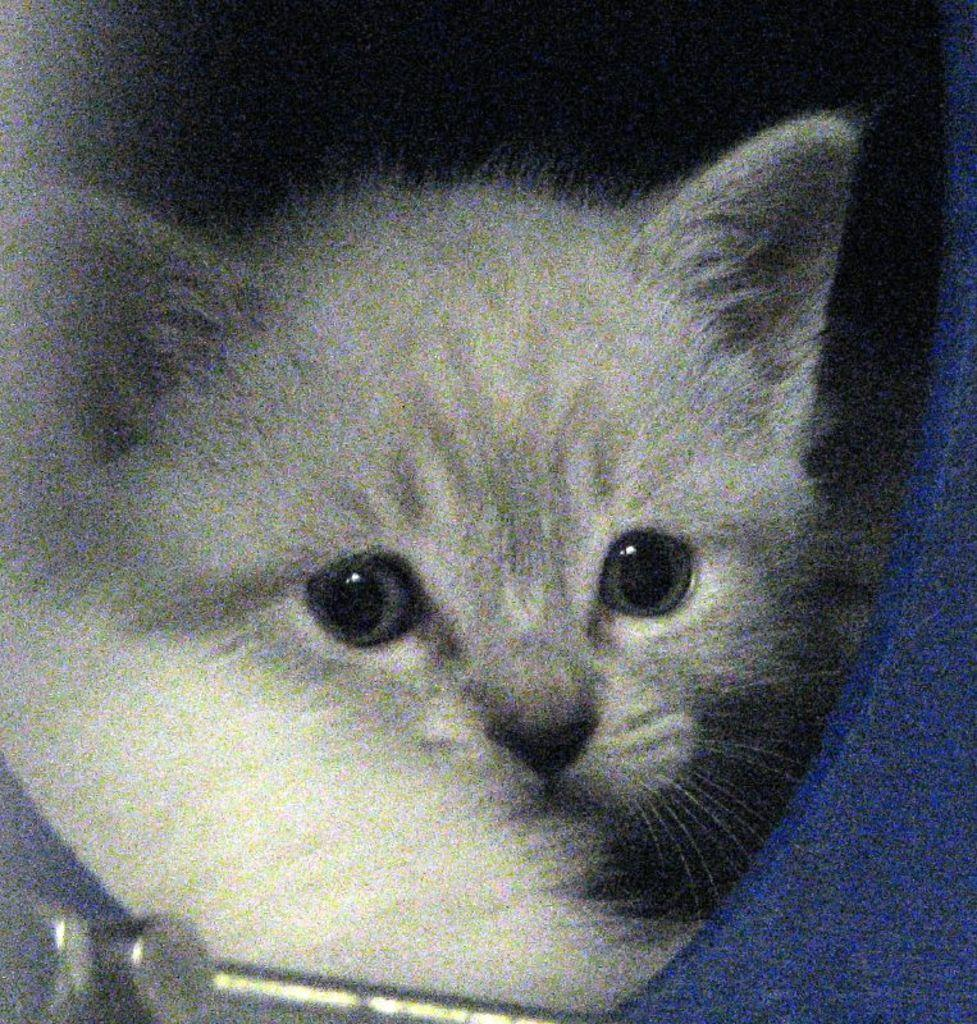What type of animal is in the image? There is a white color cat in the image. Where is the cat located in the image? The cat is present in the middle of the image. What type of arithmetic problem is the cat solving in the image? There is no arithmetic problem present in the image; it features a white color cat. How does the cat manage to burn itself in the image? There is no indication in the image that the cat is burning or has been burned. 